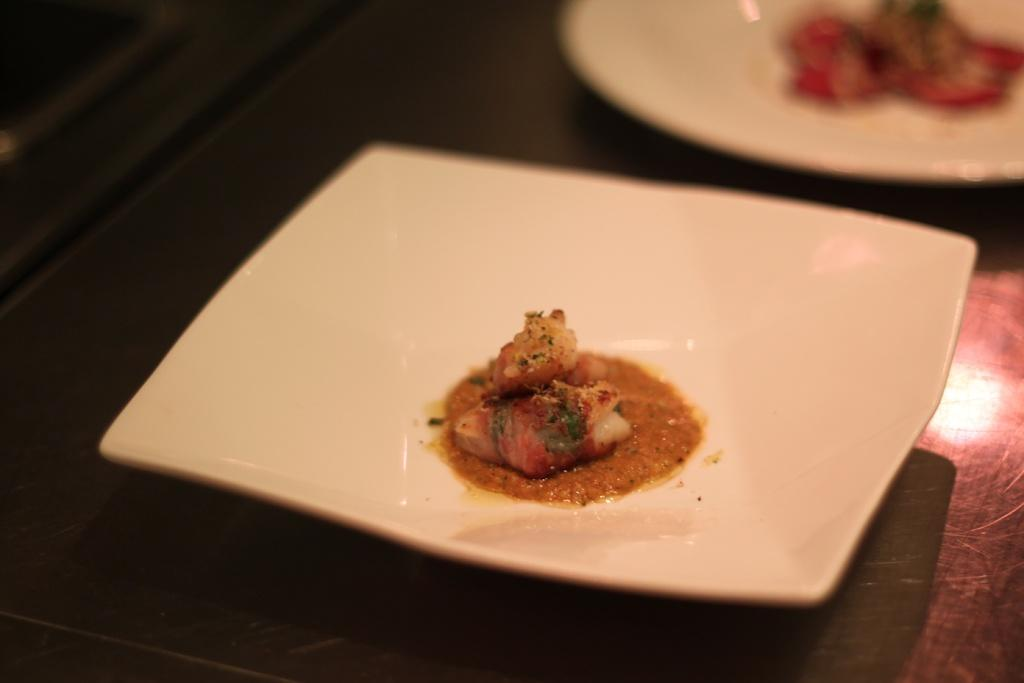What type of plates are visible in the image? There are white plates in the image. What is on the plates? The plates have food items on them. Where are the plates located? The plates are placed on a table. What type of wax can be seen melting on the plates in the image? There is no wax present in the image; the plates have food items on them. 